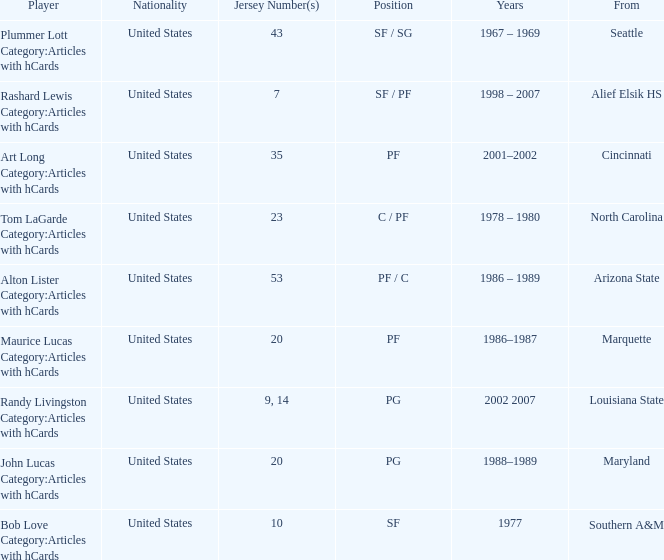The player from Alief Elsik Hs has what as a nationality? United States. 